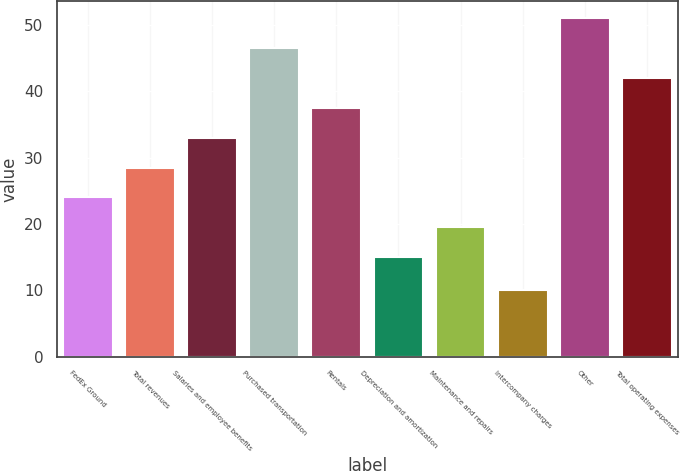<chart> <loc_0><loc_0><loc_500><loc_500><bar_chart><fcel>FedEx Ground<fcel>Total revenues<fcel>Salaries and employee benefits<fcel>Purchased transportation<fcel>Rentals<fcel>Depreciation and amortization<fcel>Maintenance and repairs<fcel>Intercompany charges<fcel>Other<fcel>Total operating expenses<nl><fcel>24<fcel>28.5<fcel>33<fcel>46.5<fcel>37.5<fcel>15<fcel>19.5<fcel>10<fcel>51<fcel>42<nl></chart> 